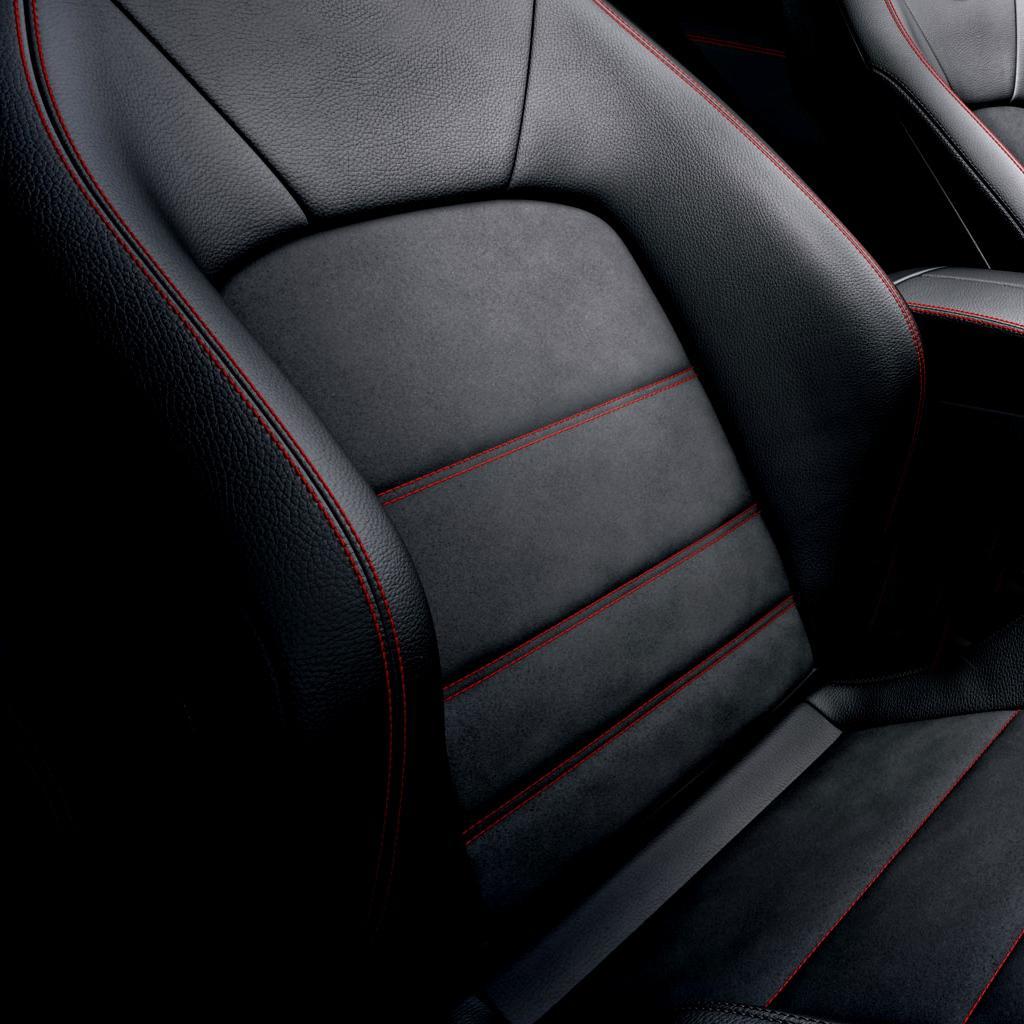Describe this image in one or two sentences. In the picture I can see a seat of a vehicle which is in black and red color. 